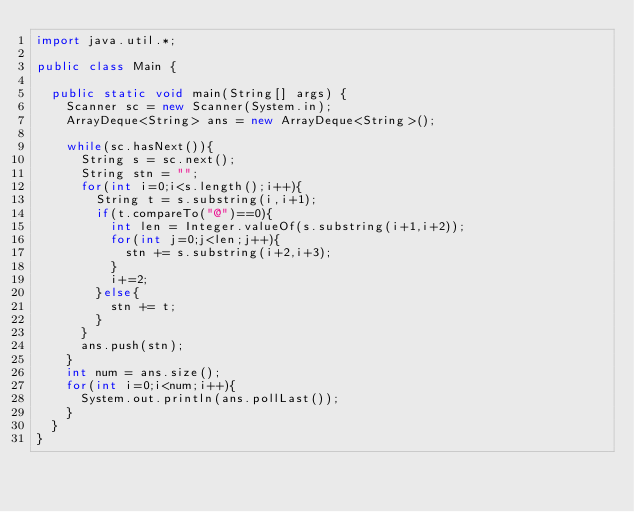Convert code to text. <code><loc_0><loc_0><loc_500><loc_500><_Java_>import java.util.*;

public class Main {

	public static void main(String[] args) {
		Scanner sc = new Scanner(System.in);
		ArrayDeque<String> ans = new ArrayDeque<String>();

		while(sc.hasNext()){
			String s = sc.next();
			String stn = "";
			for(int i=0;i<s.length();i++){
				String t = s.substring(i,i+1);
				if(t.compareTo("@")==0){
					int len = Integer.valueOf(s.substring(i+1,i+2));
					for(int j=0;j<len;j++){
						stn += s.substring(i+2,i+3);
					}
					i+=2;
				}else{
					stn += t;
				}
			}
			ans.push(stn);
		}
		int num = ans.size();
		for(int i=0;i<num;i++){
			System.out.println(ans.pollLast());
		}
	}
}</code> 